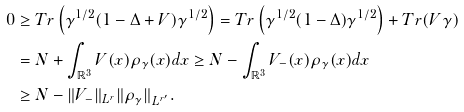<formula> <loc_0><loc_0><loc_500><loc_500>0 & \geq T r \left ( \gamma ^ { 1 / 2 } ( 1 - \Delta + V ) \gamma ^ { 1 / 2 } \right ) = T r \left ( \gamma ^ { 1 / 2 } ( 1 - \Delta ) \gamma ^ { 1 / 2 } \right ) + T r ( V \gamma ) \\ & = N + \int _ { \mathbb { R } ^ { 3 } } V ( x ) \rho _ { \gamma } ( x ) d x \geq N - \int _ { \mathbb { R } ^ { 3 } } V _ { - } ( x ) \rho _ { \gamma } ( x ) d x \\ & \geq N - \| V _ { - } \| _ { L ^ { r } } \| \rho _ { \gamma } \| _ { L ^ { r ^ { \prime } } } .</formula> 